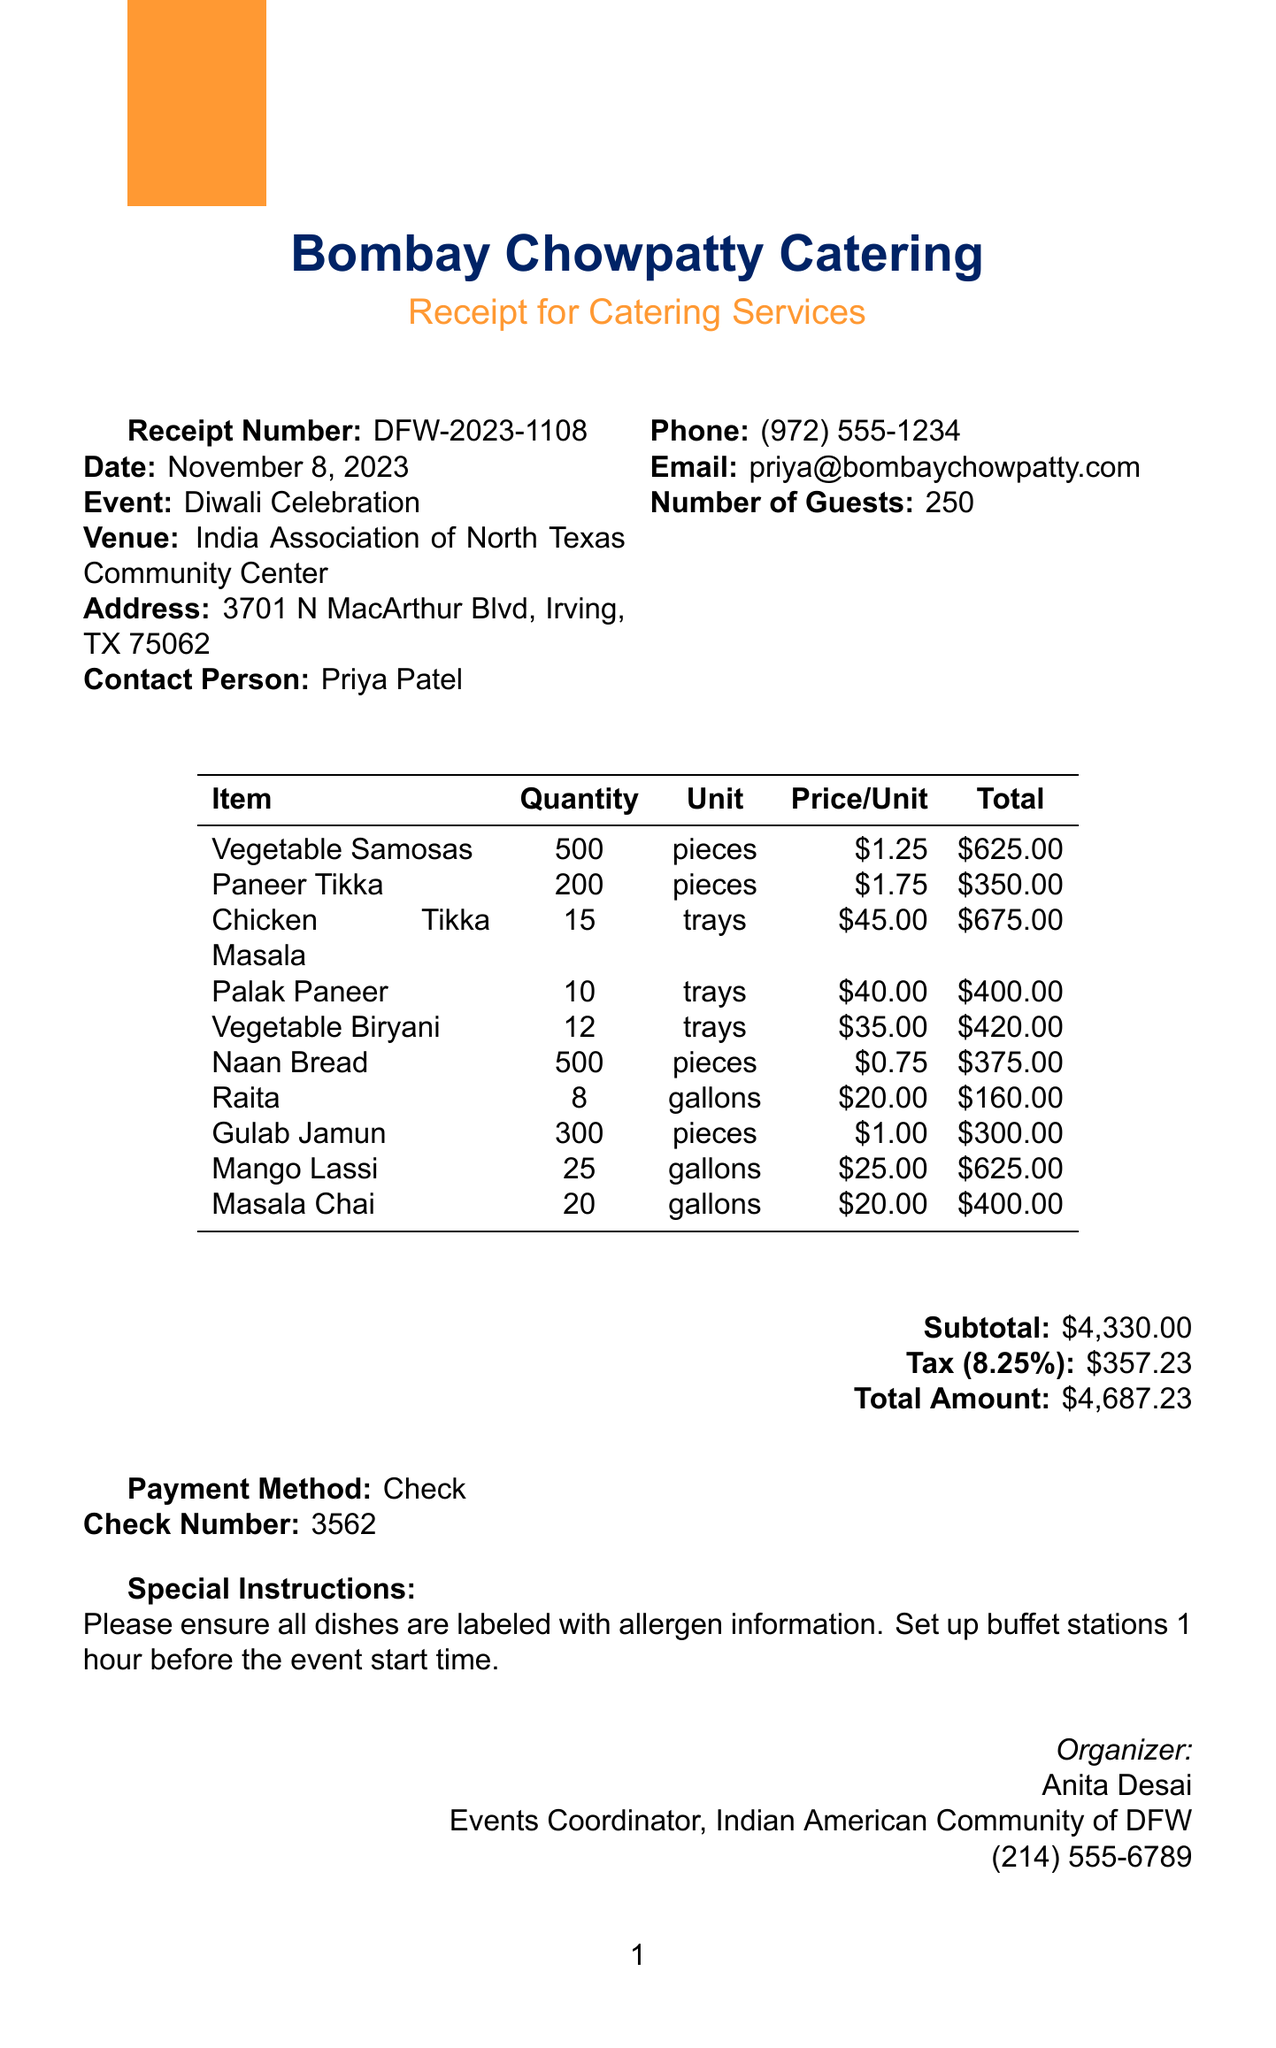What is the receipt number? The receipt number is mentioned in the document for reference, which is DFW-2023-1108.
Answer: DFW-2023-1108 What is the date of the event? The date of the Diwali Celebration event is specified in the document, which is November 8, 2023.
Answer: November 8, 2023 Who is the contact person for the catering? The document lists Priya Patel as the contact person for Bombay Chowpatty Catering.
Answer: Priya Patel How many guests are expected? The document states the expected number of guests attending the event is 250.
Answer: 250 What is the total amount due for the catering services? The total amount due, including taxes, is calculated and provided in the document as $4687.23.
Answer: $4687.23 What items are served in trays? The items listed in trays include Chicken Tikka Masala, Palak Paneer, and Vegetable Biryani, as mentioned in the itemized list.
Answer: Chicken Tikka Masala, Palak Paneer, Vegetable Biryani What special instructions are noted in the receipt? The document contains special instructions to ensure all dishes are labeled with allergen information and to set up buffet stations one hour before the event.
Answer: Ensure all dishes are labeled with allergen information What payment method was used? The document specifies that the payment method used for the catering services is Check.
Answer: Check How many pieces of Vegetable Samosas were ordered? The quantity of Vegetable Samosas ordered is listed in the itemized list, which states 500 pieces.
Answer: 500 pieces 